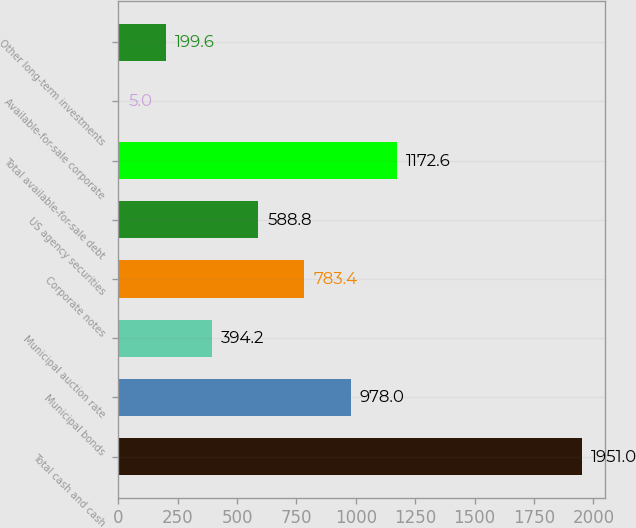Convert chart to OTSL. <chart><loc_0><loc_0><loc_500><loc_500><bar_chart><fcel>Total cash and cash<fcel>Municipal bonds<fcel>Municipal auction rate<fcel>Corporate notes<fcel>US agency securities<fcel>Total available-for-sale debt<fcel>Available-for-sale corporate<fcel>Other long-term investments<nl><fcel>1951<fcel>978<fcel>394.2<fcel>783.4<fcel>588.8<fcel>1172.6<fcel>5<fcel>199.6<nl></chart> 